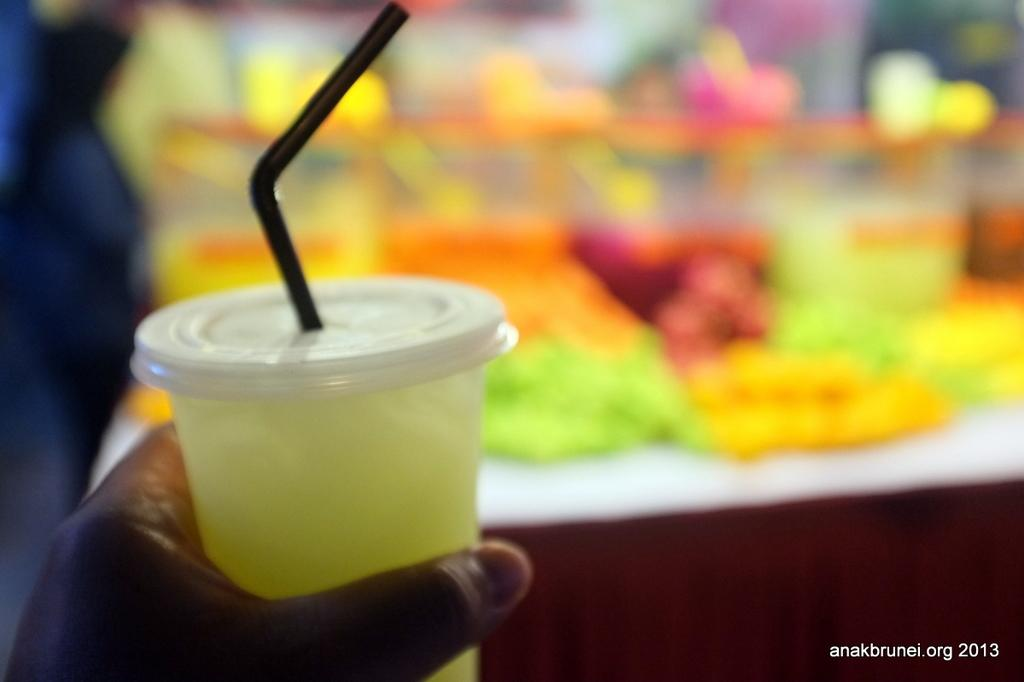What is in the image that is being held by a human? There is a glass in the image that is being held by a human. What can be inferred about the person holding the glass? The person holding the glass is likely drinking from it or about to drink from it. What can be seen in the background of the image? There are objects in the background of the image, but their specific nature is not mentioned in the facts. What direction is the zephyr blowing in the image? There is no mention of a zephyr in the image, so it cannot be determined which direction it might be blowing. 